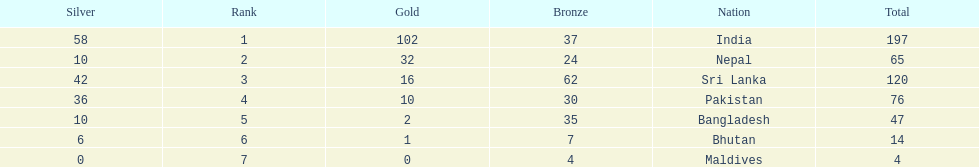Identify a country in the table that is not india. Nepal. 